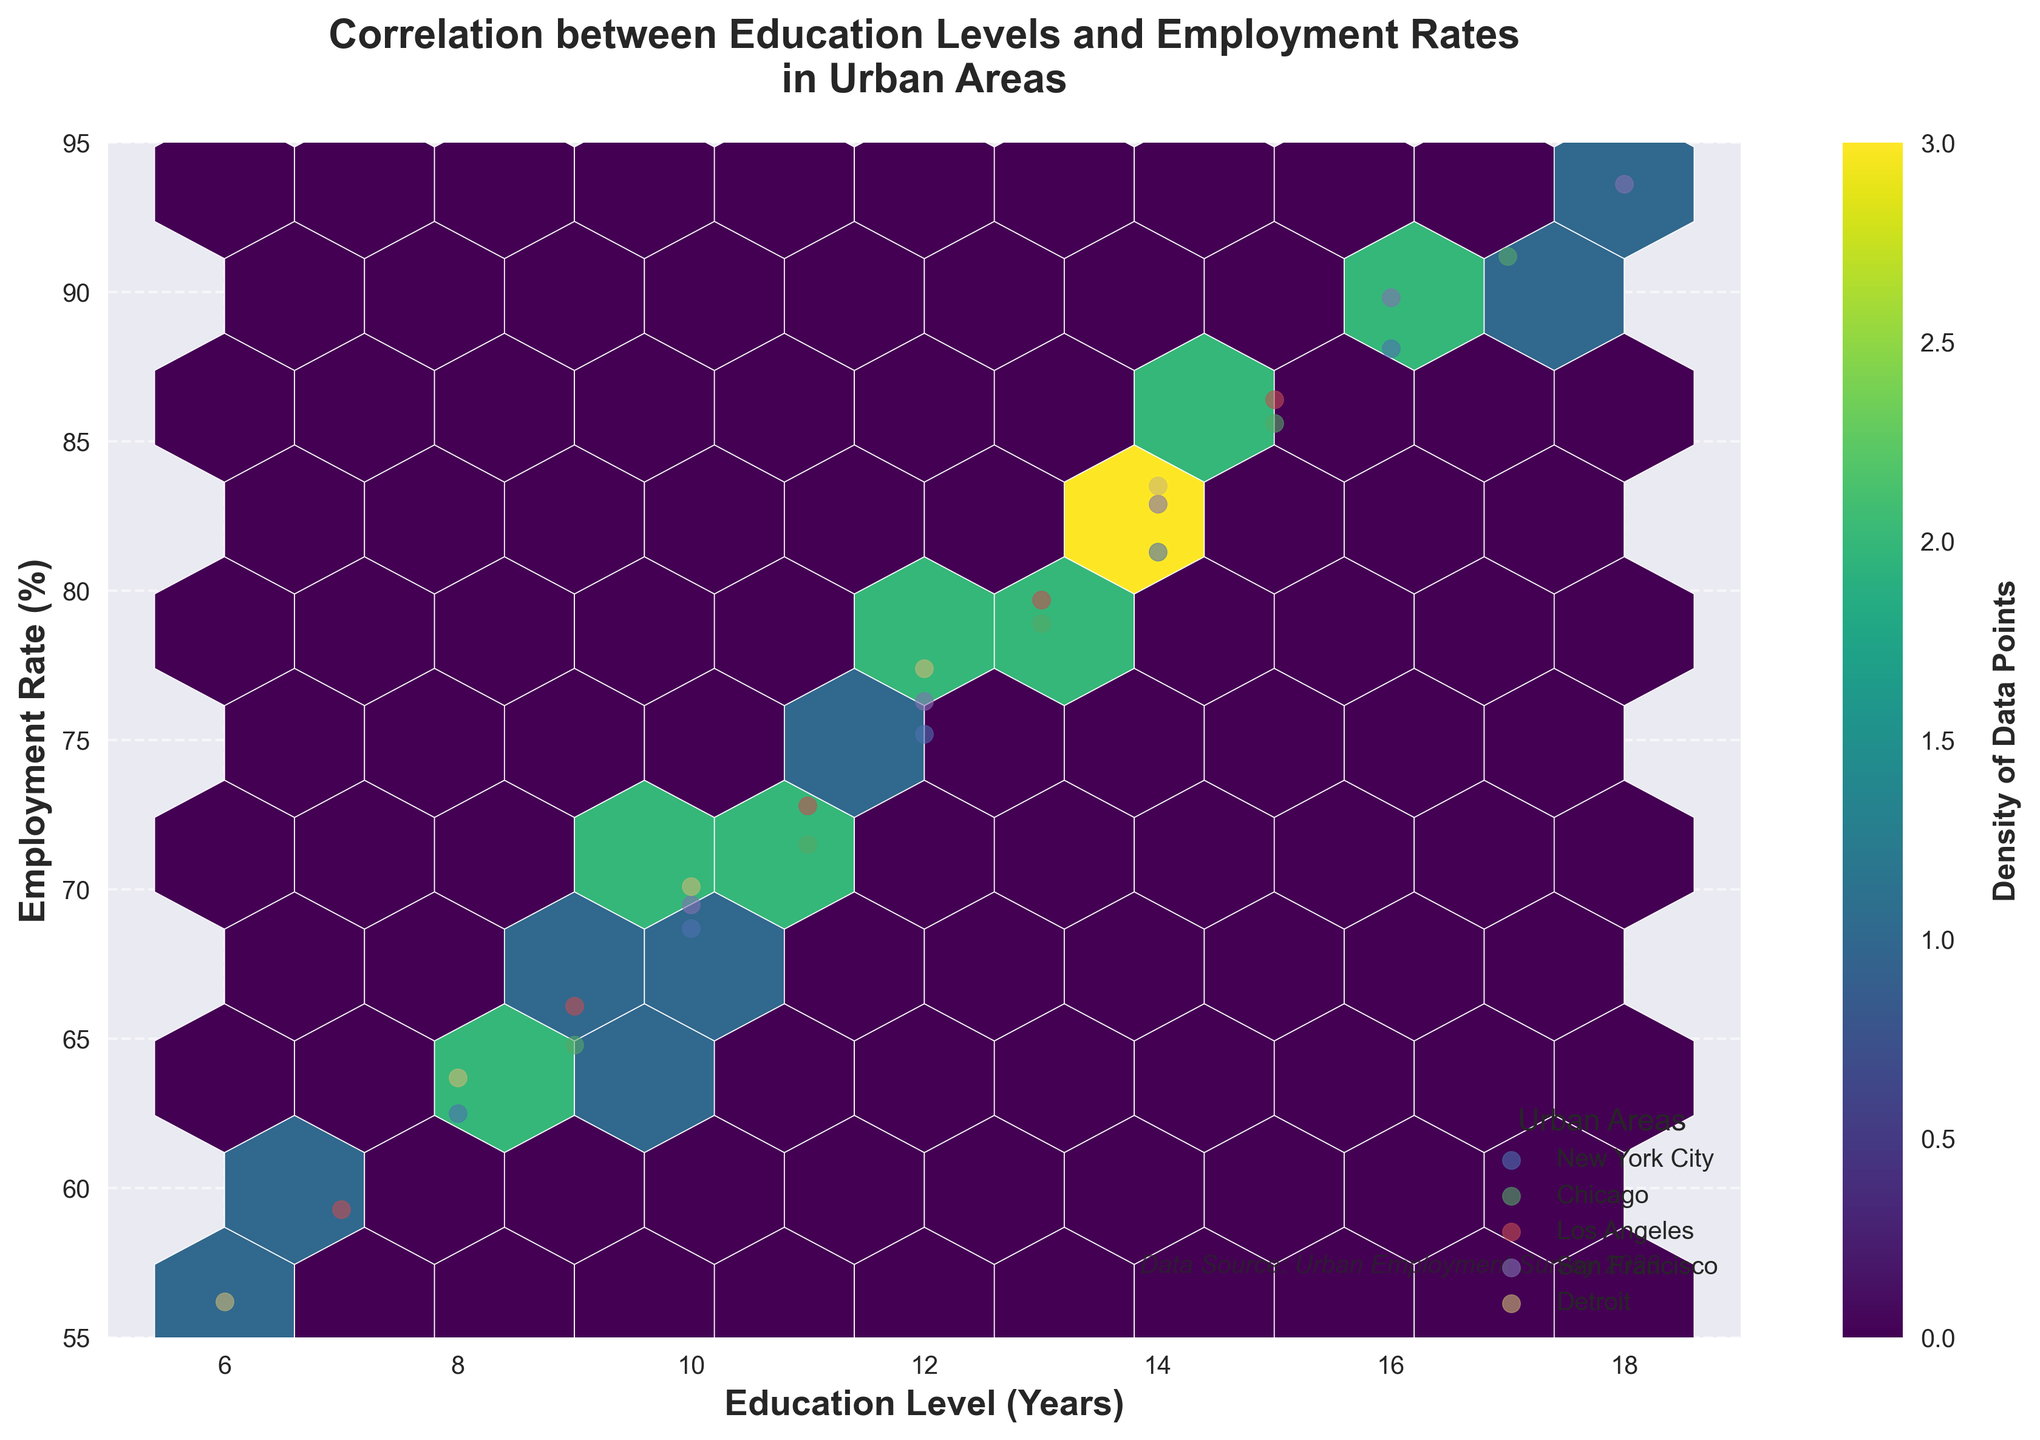What is the title of the figure? The title is displayed at the top-middle of the figure and can be read straightforwardly.
Answer: Correlation between Education Levels and Employment Rates in Urban Areas What are the labels for the x-axis and y-axis? The x-axis and y-axis labels are displayed along their respective axes. The x-axis label is 'Education Level (Years)' and the y-axis label is 'Employment Rate (%)'.
Answer: Education Level (Years) and Employment Rate (%) What is the range of values on the x-axis? The values on the x-axis range from the minimum to maximum values marked along the axis. The minimum value is 5, and the maximum value is 19.
Answer: 5 to 19 Which urban area has the highest density of data points? The color gradient in the hexbin plot indicates the density of data points. The area with the darkest hexagons represents the highest density of data points.
Answer: San Francisco What is the general trend between education level and employment rate as shown in the plot? The overall trend can be observed by following the direction of the hexagons and the proximal scatter points for different cities. The scatter and hexagons generally show an upward trend from lower to higher education levels, indicating a positive correlation.
Answer: Positive correlation In which urban areas does an education level of 10 years correspond to an employment rate of around 70%? By looking at the intersection points for an education level of 10 on the x-axis and approximately 70% on the y-axis and identifying the scatter points, we can identify the urban areas. These are marked around the points (10, 68.7) for New York City, (10, 69.5) for Los Angeles, and (10, 70.1) for Detroit.
Answer: New York City, Los Angeles, Detroit Which urban area shows the highest employment rate for the highest education level? By examining the city labels and the scatter points at the highest education levels along the x-axis, we can identify that San Francisco shows the highest employment rate corresponding to the highest education levels (e.g., (18, 93.6)).
Answer: San Francisco What is the legend title in the bottom right corner of the figure? The legend title is located in the legend box. The title describes what each color represents.
Answer: Urban Areas How does the employment rate change with education levels between Los Angeles and Chicago? By comparing the scatter points for Los Angeles and Chicago cities across similar education levels, we observe the relative employment rates. For instance, at 15 years of education, Los Angeles has an employment rate of 86.4%, while Chicago has an employment rate of 85.6%.
Answer: Employment rates generally increase with education levels in both cities, but the specific rates at similar education levels vary slightly What is the employment rate range observed in the data? By identifying the extreme points along the y-axis (considering both the scatter points and the limits), we can determine the range. The range goes from the minimum employment rate of 55% to the maximum employment rate of 95%.
Answer: 55% to 95% 